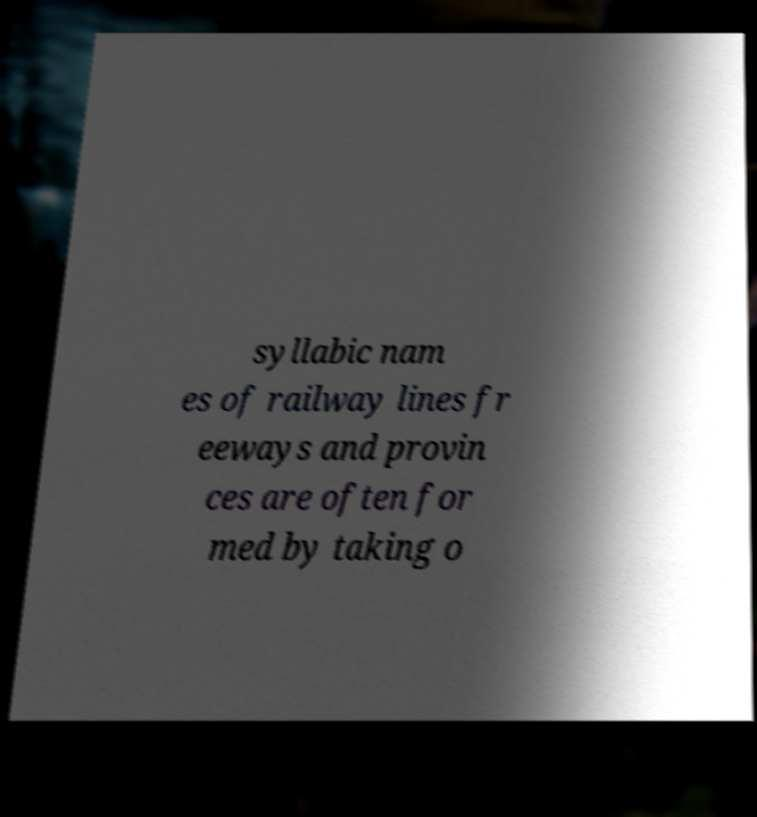I need the written content from this picture converted into text. Can you do that? syllabic nam es of railway lines fr eeways and provin ces are often for med by taking o 